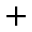<formula> <loc_0><loc_0><loc_500><loc_500>+</formula> 